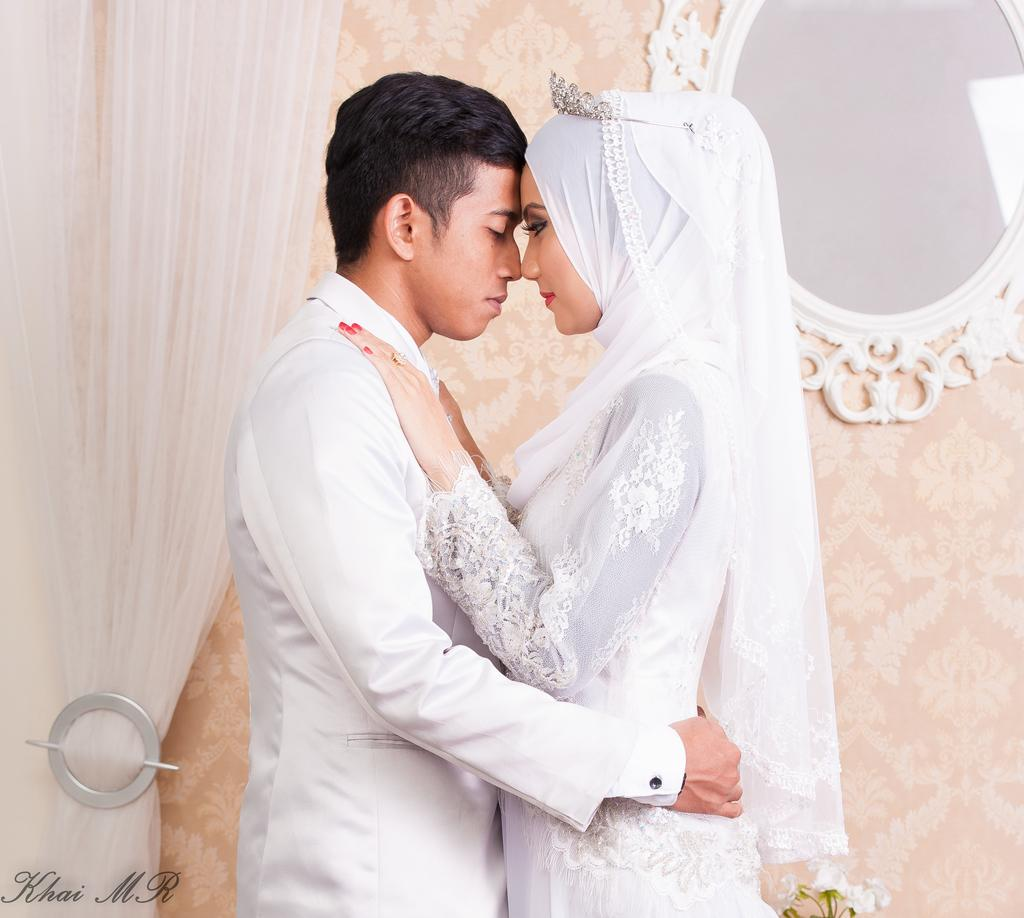Who can be seen in the image? There is a couple standing in the image. What is visible in the background of the image? There is a wall in the background of the image. What is associated with the wall in the image? There is a curtain associated with the wall. What is on the wall in the background? There is a mirror on the wall in the background. What direction is the blade pointing in the image? There is no blade present in the image. How many times does the couple twist in the image? The couple is not twisting in the image; they are standing still. 